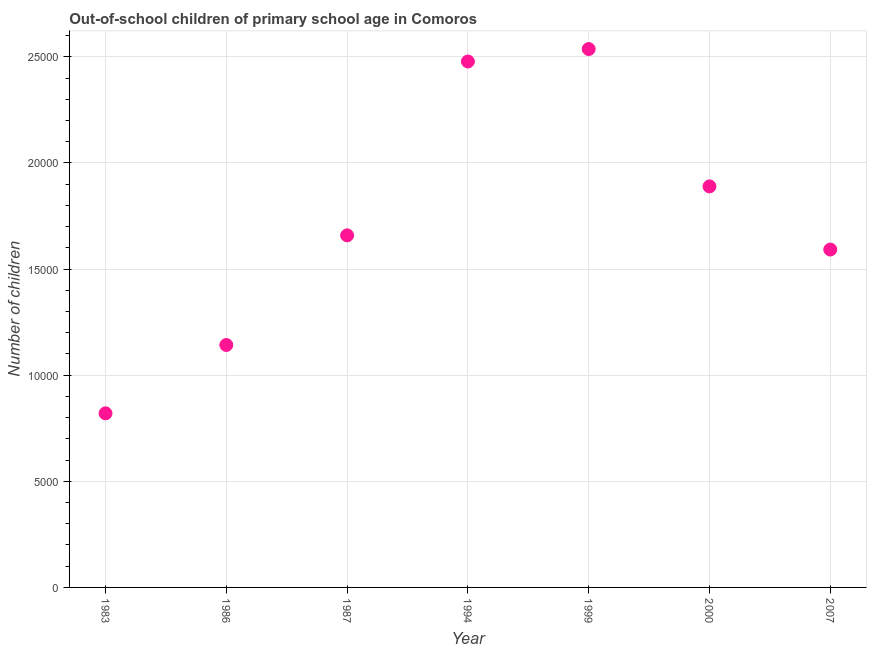What is the number of out-of-school children in 1983?
Offer a very short reply. 8203. Across all years, what is the maximum number of out-of-school children?
Your answer should be compact. 2.54e+04. Across all years, what is the minimum number of out-of-school children?
Your answer should be compact. 8203. In which year was the number of out-of-school children maximum?
Your response must be concise. 1999. In which year was the number of out-of-school children minimum?
Offer a very short reply. 1983. What is the sum of the number of out-of-school children?
Keep it short and to the point. 1.21e+05. What is the difference between the number of out-of-school children in 1999 and 2007?
Your answer should be very brief. 9447. What is the average number of out-of-school children per year?
Your response must be concise. 1.73e+04. What is the median number of out-of-school children?
Give a very brief answer. 1.66e+04. What is the ratio of the number of out-of-school children in 2000 to that in 2007?
Offer a very short reply. 1.19. Is the number of out-of-school children in 1986 less than that in 1994?
Your response must be concise. Yes. Is the difference between the number of out-of-school children in 1999 and 2007 greater than the difference between any two years?
Make the answer very short. No. What is the difference between the highest and the second highest number of out-of-school children?
Your answer should be compact. 587. Is the sum of the number of out-of-school children in 1987 and 1994 greater than the maximum number of out-of-school children across all years?
Your answer should be very brief. Yes. What is the difference between the highest and the lowest number of out-of-school children?
Your answer should be compact. 1.72e+04. In how many years, is the number of out-of-school children greater than the average number of out-of-school children taken over all years?
Offer a terse response. 3. Does the number of out-of-school children monotonically increase over the years?
Offer a terse response. No. How many dotlines are there?
Your response must be concise. 1. How many years are there in the graph?
Ensure brevity in your answer.  7. What is the difference between two consecutive major ticks on the Y-axis?
Your answer should be very brief. 5000. Does the graph contain any zero values?
Provide a short and direct response. No. Does the graph contain grids?
Provide a succinct answer. Yes. What is the title of the graph?
Provide a succinct answer. Out-of-school children of primary school age in Comoros. What is the label or title of the Y-axis?
Offer a terse response. Number of children. What is the Number of children in 1983?
Make the answer very short. 8203. What is the Number of children in 1986?
Your response must be concise. 1.14e+04. What is the Number of children in 1987?
Make the answer very short. 1.66e+04. What is the Number of children in 1994?
Provide a short and direct response. 2.48e+04. What is the Number of children in 1999?
Offer a very short reply. 2.54e+04. What is the Number of children in 2000?
Keep it short and to the point. 1.89e+04. What is the Number of children in 2007?
Ensure brevity in your answer.  1.59e+04. What is the difference between the Number of children in 1983 and 1986?
Your answer should be very brief. -3220. What is the difference between the Number of children in 1983 and 1987?
Keep it short and to the point. -8385. What is the difference between the Number of children in 1983 and 1994?
Provide a succinct answer. -1.66e+04. What is the difference between the Number of children in 1983 and 1999?
Provide a succinct answer. -1.72e+04. What is the difference between the Number of children in 1983 and 2000?
Ensure brevity in your answer.  -1.07e+04. What is the difference between the Number of children in 1983 and 2007?
Your answer should be very brief. -7716. What is the difference between the Number of children in 1986 and 1987?
Your answer should be compact. -5165. What is the difference between the Number of children in 1986 and 1994?
Keep it short and to the point. -1.34e+04. What is the difference between the Number of children in 1986 and 1999?
Ensure brevity in your answer.  -1.39e+04. What is the difference between the Number of children in 1986 and 2000?
Ensure brevity in your answer.  -7472. What is the difference between the Number of children in 1986 and 2007?
Provide a succinct answer. -4496. What is the difference between the Number of children in 1987 and 1994?
Your response must be concise. -8191. What is the difference between the Number of children in 1987 and 1999?
Make the answer very short. -8778. What is the difference between the Number of children in 1987 and 2000?
Your answer should be compact. -2307. What is the difference between the Number of children in 1987 and 2007?
Your answer should be very brief. 669. What is the difference between the Number of children in 1994 and 1999?
Keep it short and to the point. -587. What is the difference between the Number of children in 1994 and 2000?
Make the answer very short. 5884. What is the difference between the Number of children in 1994 and 2007?
Provide a succinct answer. 8860. What is the difference between the Number of children in 1999 and 2000?
Provide a short and direct response. 6471. What is the difference between the Number of children in 1999 and 2007?
Give a very brief answer. 9447. What is the difference between the Number of children in 2000 and 2007?
Your answer should be compact. 2976. What is the ratio of the Number of children in 1983 to that in 1986?
Provide a short and direct response. 0.72. What is the ratio of the Number of children in 1983 to that in 1987?
Make the answer very short. 0.49. What is the ratio of the Number of children in 1983 to that in 1994?
Provide a succinct answer. 0.33. What is the ratio of the Number of children in 1983 to that in 1999?
Your answer should be compact. 0.32. What is the ratio of the Number of children in 1983 to that in 2000?
Ensure brevity in your answer.  0.43. What is the ratio of the Number of children in 1983 to that in 2007?
Your answer should be very brief. 0.52. What is the ratio of the Number of children in 1986 to that in 1987?
Ensure brevity in your answer.  0.69. What is the ratio of the Number of children in 1986 to that in 1994?
Provide a short and direct response. 0.46. What is the ratio of the Number of children in 1986 to that in 1999?
Make the answer very short. 0.45. What is the ratio of the Number of children in 1986 to that in 2000?
Ensure brevity in your answer.  0.6. What is the ratio of the Number of children in 1986 to that in 2007?
Provide a succinct answer. 0.72. What is the ratio of the Number of children in 1987 to that in 1994?
Offer a very short reply. 0.67. What is the ratio of the Number of children in 1987 to that in 1999?
Your response must be concise. 0.65. What is the ratio of the Number of children in 1987 to that in 2000?
Give a very brief answer. 0.88. What is the ratio of the Number of children in 1987 to that in 2007?
Your response must be concise. 1.04. What is the ratio of the Number of children in 1994 to that in 1999?
Your answer should be very brief. 0.98. What is the ratio of the Number of children in 1994 to that in 2000?
Your answer should be compact. 1.31. What is the ratio of the Number of children in 1994 to that in 2007?
Your response must be concise. 1.56. What is the ratio of the Number of children in 1999 to that in 2000?
Your response must be concise. 1.34. What is the ratio of the Number of children in 1999 to that in 2007?
Offer a very short reply. 1.59. What is the ratio of the Number of children in 2000 to that in 2007?
Your answer should be compact. 1.19. 